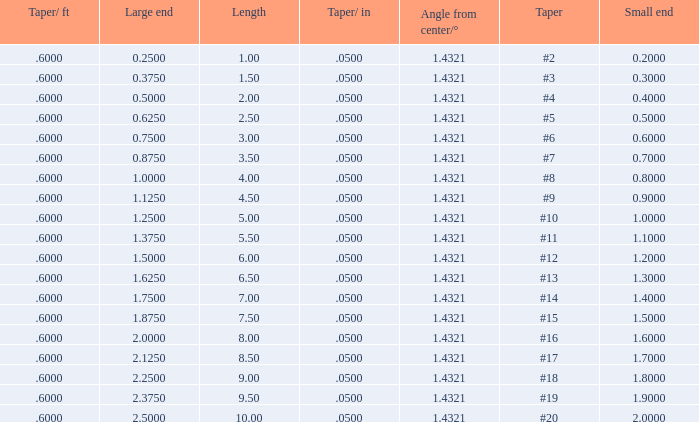Which Taper/in that has a Small end larger than 0.7000000000000001, and a Taper of #19, and a Large end larger than 2.375? None. 